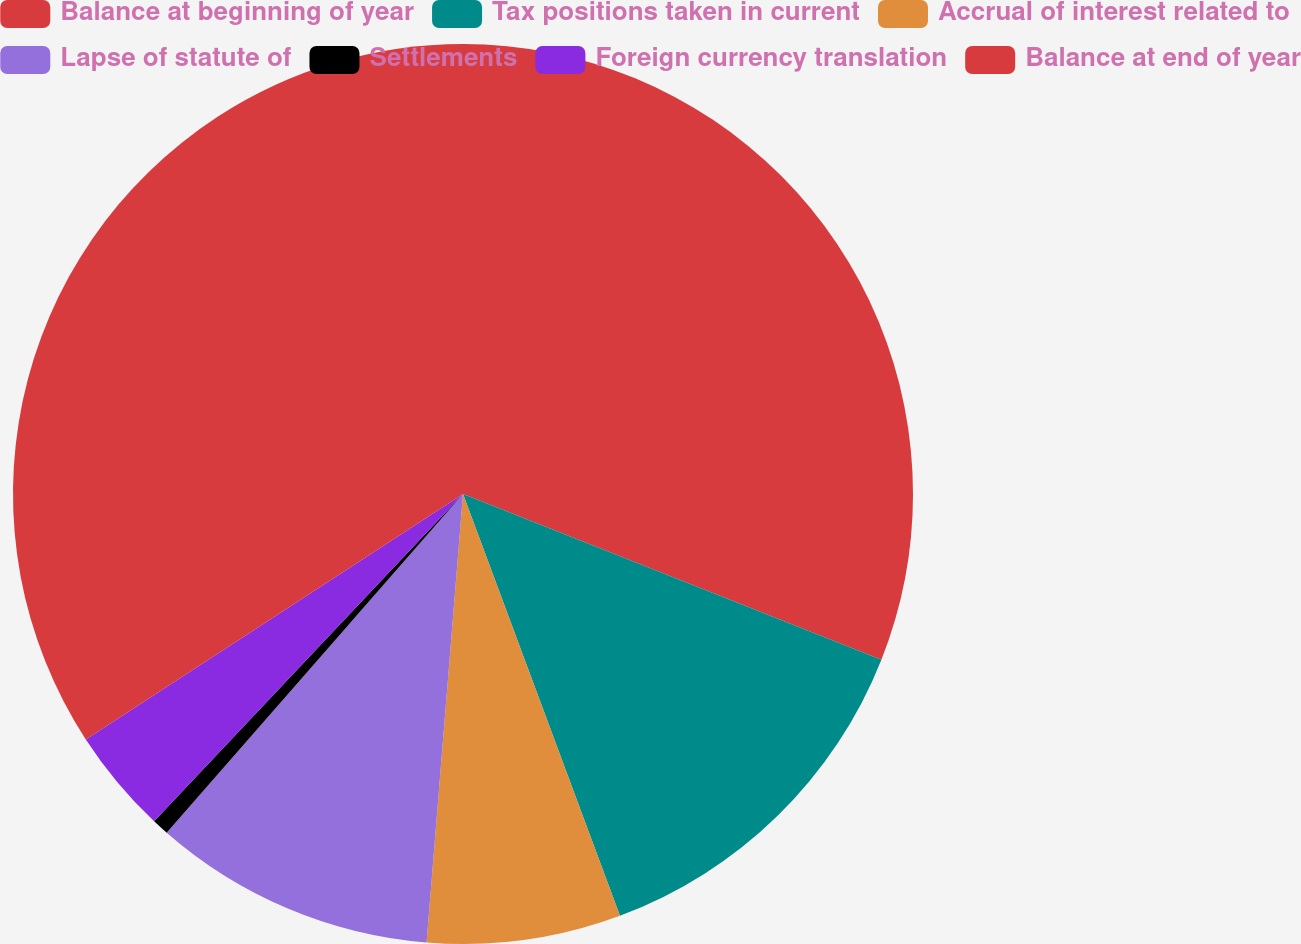Convert chart to OTSL. <chart><loc_0><loc_0><loc_500><loc_500><pie_chart><fcel>Balance at beginning of year<fcel>Tax positions taken in current<fcel>Accrual of interest related to<fcel>Lapse of statute of<fcel>Settlements<fcel>Foreign currency translation<fcel>Balance at end of year<nl><fcel>31.0%<fcel>13.33%<fcel>6.96%<fcel>10.15%<fcel>0.6%<fcel>3.78%<fcel>34.18%<nl></chart> 